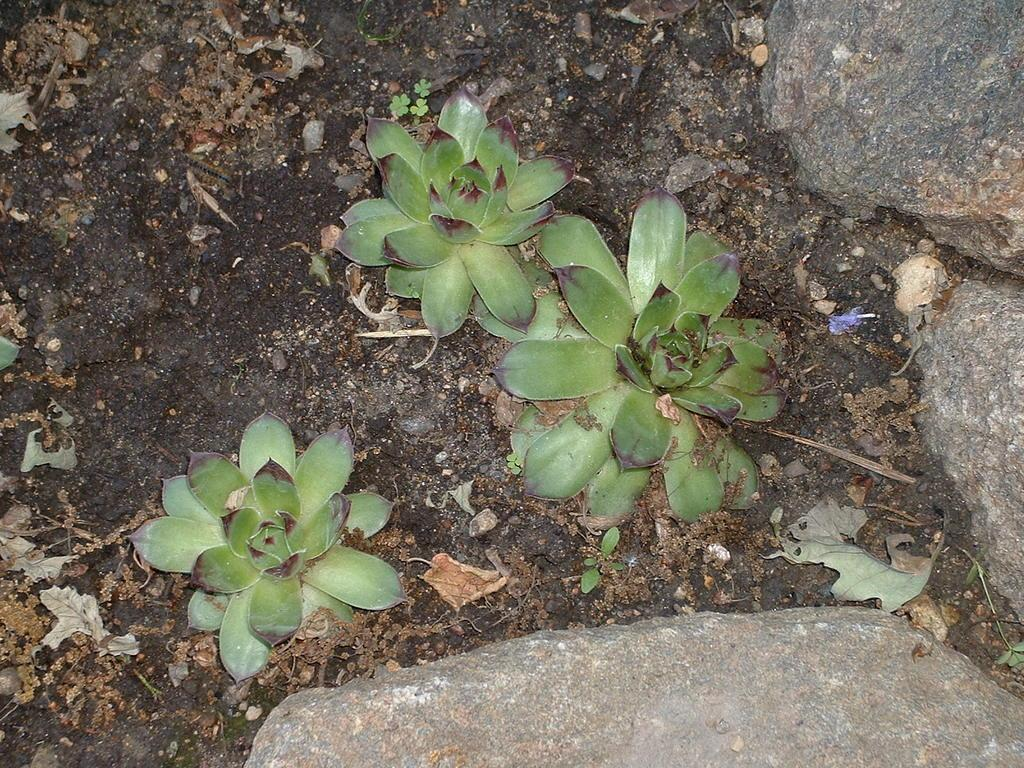What type of terrain is visible in the image? There is a muddy path in the image. What can be seen growing on the path? There are three plants with leaves on the path. What additional objects are present near the path? There are three rocks beside the path. What type of brick structure can be seen in the image? There is no brick structure present in the image; it features a muddy path with plants and rocks. How does the carriage move along the path in the image? There is no carriage present in the image, so it cannot be determined how it would move along the path. 